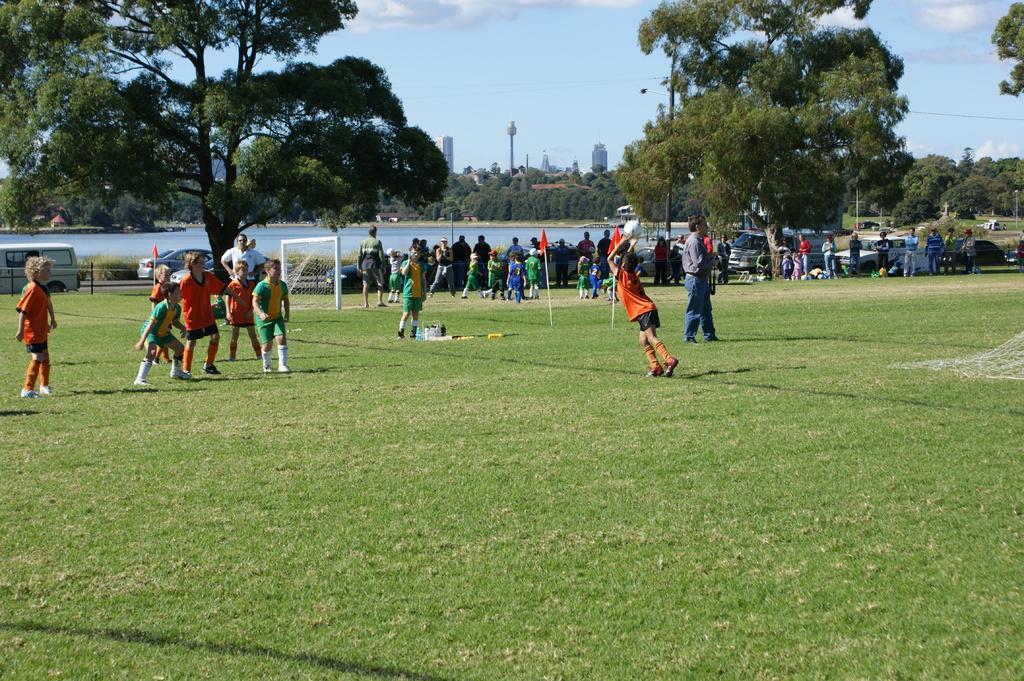Please provide a concise description of this image. In this image there are a few kids playing football, behind them there is goal post, flags, some other objects and a few people walking, behind them there are cars parked, in the background of the image there are trees, a river, buildings, at the top of the image there are clouds in the sky. 